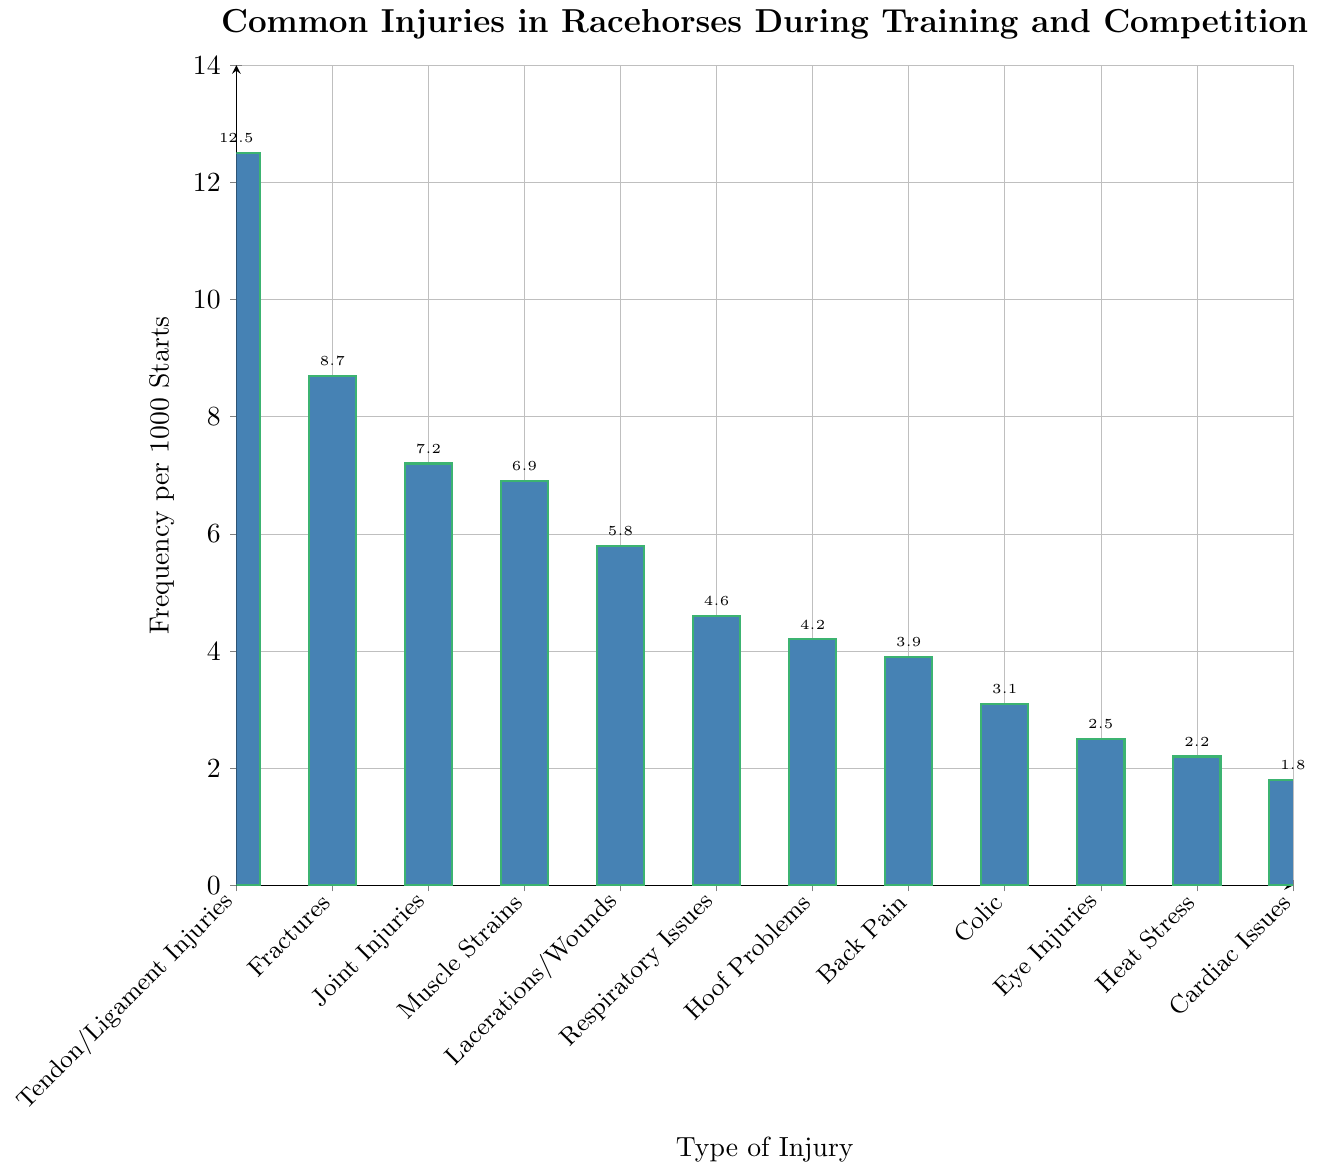What type of injury occurs most frequently in racehorses during training and competition? The bar for "Tendon/Ligament Injuries" is the tallest, indicating the highest frequency value.
Answer: Tendon/Ligament Injuries Which two types of injuries have a combined frequency of over 15 per 1000 starts? Adding the frequencies of "Fractures" (8.7) and "Joint Injuries" (7.2) gives 15.9 and adding "Fractures" (8.7) and "Muscle Strains" (6.9) gives 15.6, both exceed 15.
Answer: Fractures and Joint Injuries; Fractures and Muscle Strains How many types of injuries have a frequency lower than 5 per 1000 starts? By counting bars with height less than 5, we have six: "Respiratory Issues", "Hoof Problems", "Back Pain", "Colic", "Eye Injuries", "Heat Stress", and "Cardiac Issues".
Answer: 7 Is the frequency of Eye Injuries greater than that of Heat Stress and Cardiac Issues combined? The frequency for Eye Injuries is 2.5; the combined frequency of Heat Stress and Cardiac Issues is 4.0 (2.2 + 1.8). Ey Injuries (2.5) is less than 4.0.
Answer: No What's the difference in frequency between the most common injury and the least common injury? The most common injury is "Tendon/Ligament Injuries" at 12.5, and the least common is "Cardiac Issues" at 1.8. Subtracting these gives 10.7 (12.5 - 1.8).
Answer: 10.7 Which injuries have a frequency close to the average frequency of all types? Adding all frequencies and dividing by the number of types: (12.5 + 8.7 + 7.2 + 6.9 + 5.8 + 4.6 + 4.2 + 3.9 + 3.1 + 2.5 + 2.2 + 1.8) / 12 = 5.08. "Lacerations/Wounds" (5.8) and "Respiratory Issues" (4.6) are closest.
Answer: Lacerations/Wounds and Respiratory Issues Which types of injuries are less frequent than Hoof Problems but more frequent than Cardiac Issues? Hoof Problems has a frequency of 4.2, and Cardiac Issues has 1.8. "Back Pain" (3.9), "Colic" (3.1), "Eye Injuries" (2.5), and "Heat Stress" (2.2) meet this criterion.
Answer: Back Pain, Colic, Eye Injuries, and Heat Stress 